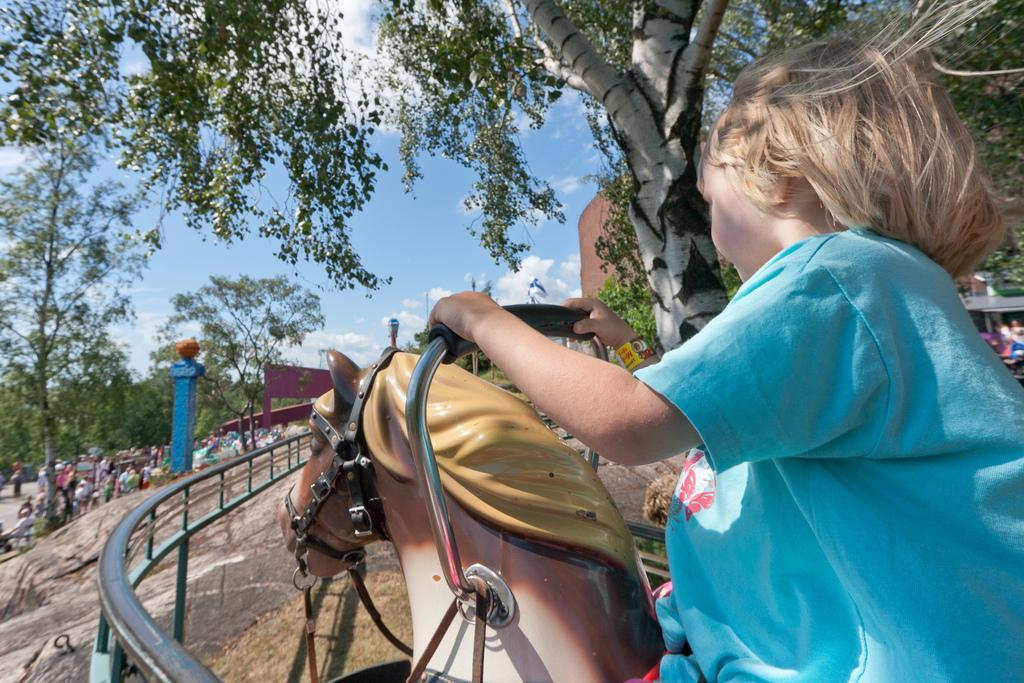How would you summarize this image in a sentence or two? In this picture there is a child sitting on a toy horse. There is tree, railing, building and sky in the image. To the left corner there is crowd.  